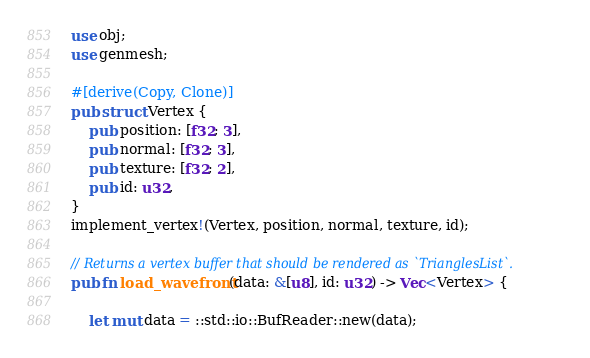Convert code to text. <code><loc_0><loc_0><loc_500><loc_500><_Rust_>use obj;
use genmesh;

#[derive(Copy, Clone)]
pub struct Vertex {
    pub position: [f32; 3],
    pub normal: [f32; 3],
    pub texture: [f32; 2],
    pub id: u32,
}
implement_vertex!(Vertex, position, normal, texture, id);

// Returns a vertex buffer that should be rendered as `TrianglesList`.
pub fn load_wavefront(data: &[u8], id: u32) -> Vec<Vertex> {

    let mut data = ::std::io::BufReader::new(data);</code> 